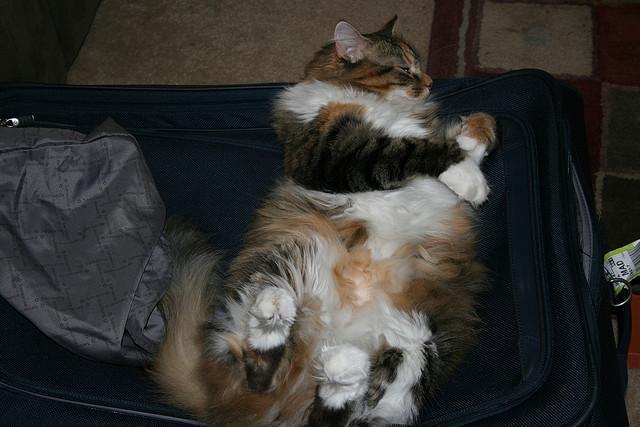How many cats are visible in the picture?
Give a very brief answer. 1. 